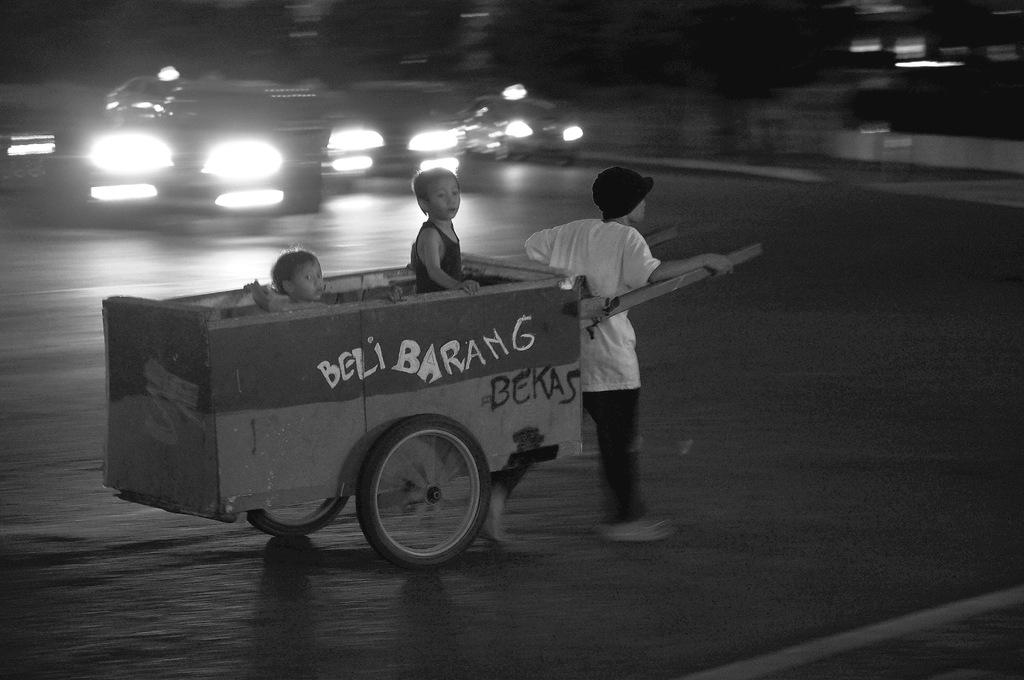What can be seen on the road in the image? There are vehicles on the road in the image. What is the person in the image doing? The person is dragging an object in the image. Who is on the object being dragged? Children are visible on the object being dragged. What is the color scheme of the image? The image is black and white in color. How many eggs are being used as a spy in the image? There are no eggs or spies present in the image. What part of the object being dragged is the most colorful? The image is black and white, so there are no colorful parts on the object being dragged. 